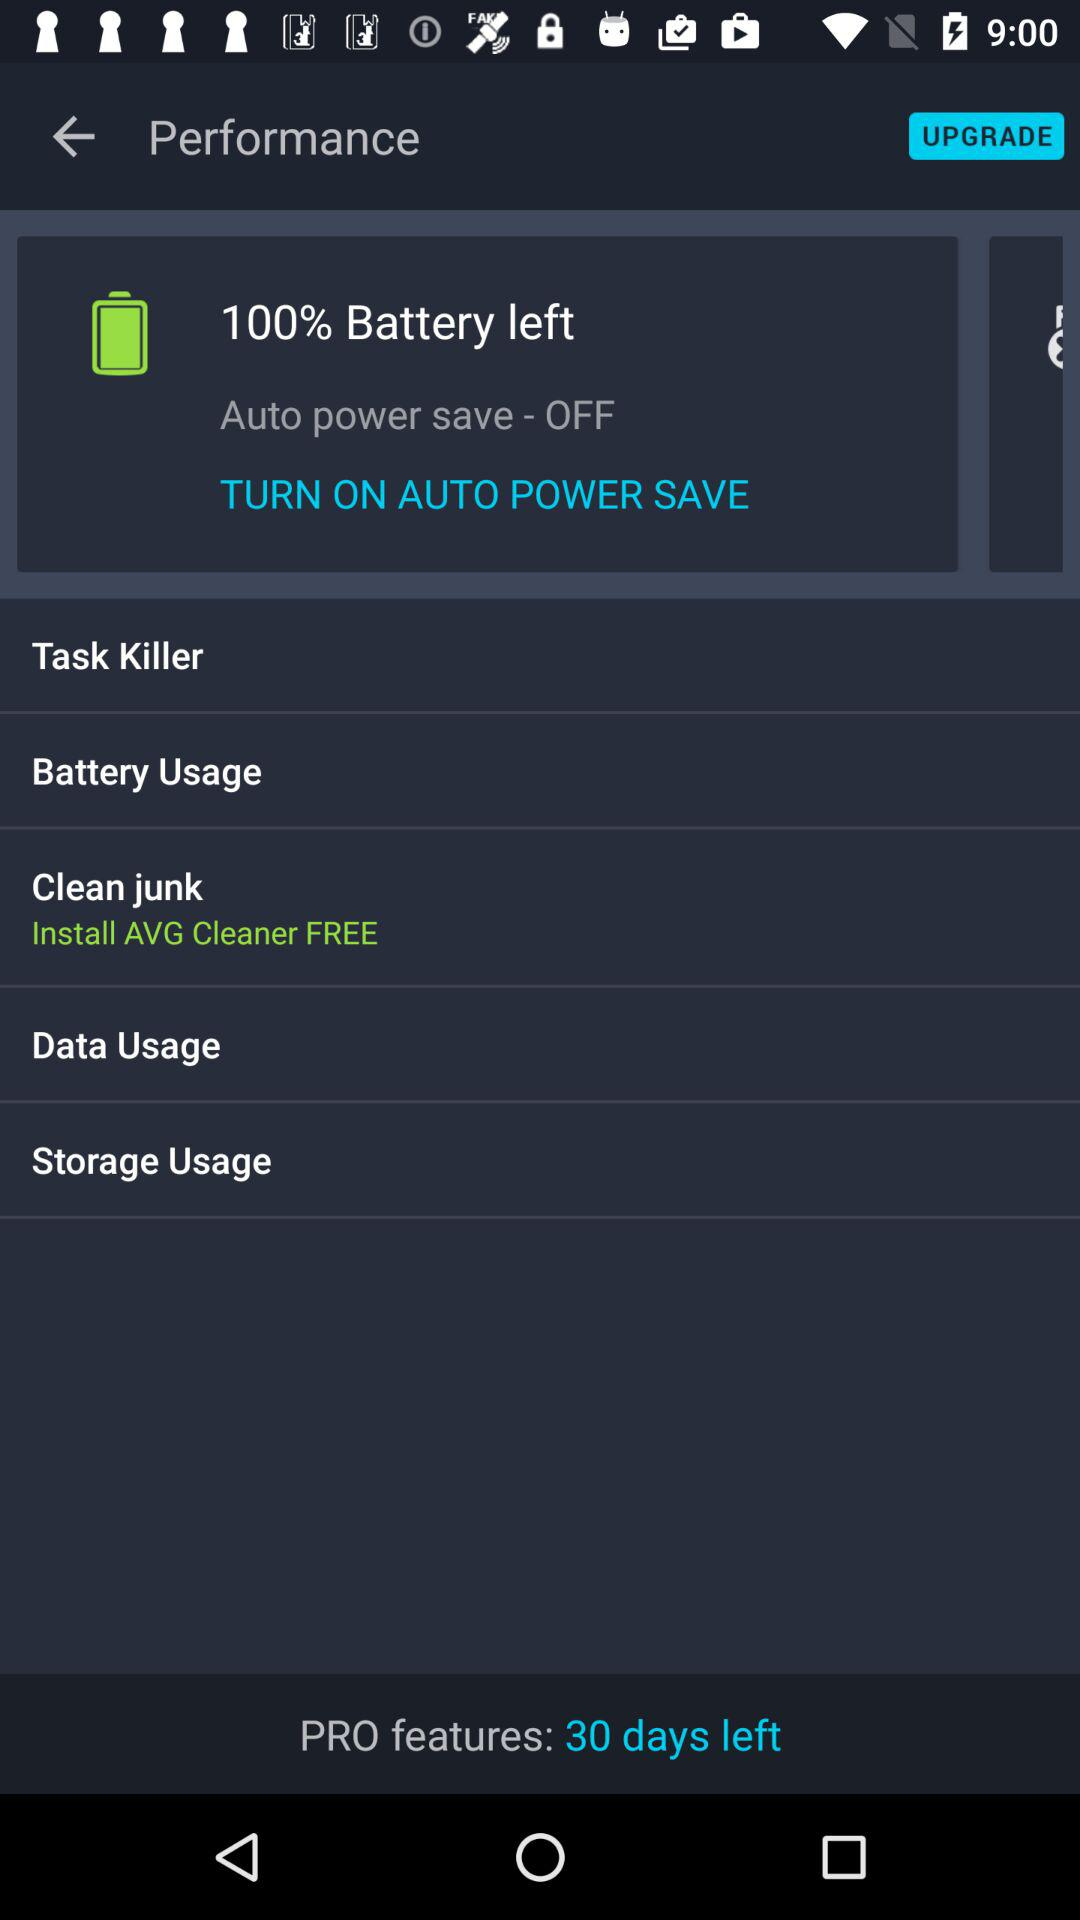How much is the storage usage?
When the provided information is insufficient, respond with <no answer>. <no answer> 